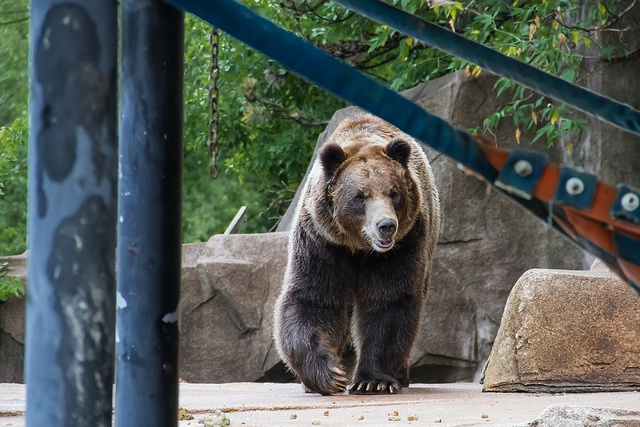Describe the objects in this image and their specific colors. I can see a bear in green, black, gray, darkgray, and lightgray tones in this image. 